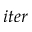Convert formula to latex. <formula><loc_0><loc_0><loc_500><loc_500>i t e r</formula> 